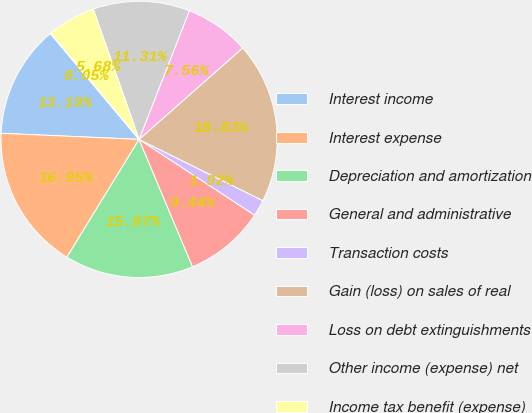Convert chart. <chart><loc_0><loc_0><loc_500><loc_500><pie_chart><fcel>Interest income<fcel>Interest expense<fcel>Depreciation and amortization<fcel>General and administrative<fcel>Transaction costs<fcel>Gain (loss) on sales of real<fcel>Loss on debt extinguishments<fcel>Other income (expense) net<fcel>Income tax benefit (expense)<fcel>Equity income (loss) from<nl><fcel>13.19%<fcel>16.95%<fcel>15.07%<fcel>9.44%<fcel>1.92%<fcel>18.83%<fcel>7.56%<fcel>11.31%<fcel>5.68%<fcel>0.05%<nl></chart> 